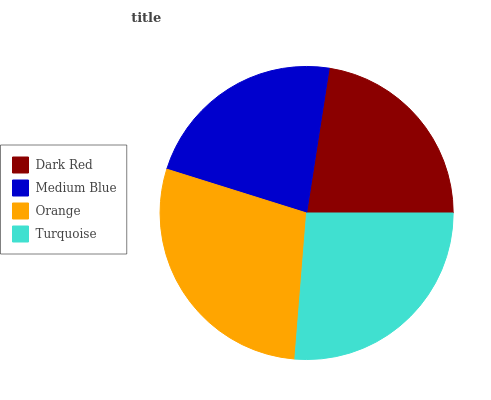Is Dark Red the minimum?
Answer yes or no. Yes. Is Orange the maximum?
Answer yes or no. Yes. Is Medium Blue the minimum?
Answer yes or no. No. Is Medium Blue the maximum?
Answer yes or no. No. Is Medium Blue greater than Dark Red?
Answer yes or no. Yes. Is Dark Red less than Medium Blue?
Answer yes or no. Yes. Is Dark Red greater than Medium Blue?
Answer yes or no. No. Is Medium Blue less than Dark Red?
Answer yes or no. No. Is Turquoise the high median?
Answer yes or no. Yes. Is Medium Blue the low median?
Answer yes or no. Yes. Is Medium Blue the high median?
Answer yes or no. No. Is Dark Red the low median?
Answer yes or no. No. 